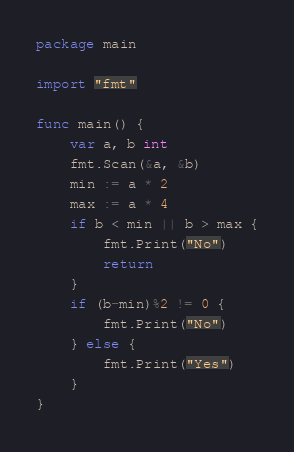Convert code to text. <code><loc_0><loc_0><loc_500><loc_500><_Go_>package main

import "fmt"

func main() {
	var a, b int
	fmt.Scan(&a, &b)
	min := a * 2
	max := a * 4
	if b < min || b > max {
		fmt.Print("No")
		return
	}
	if (b-min)%2 != 0 {
		fmt.Print("No")
	} else {
		fmt.Print("Yes")
	}
}
</code> 